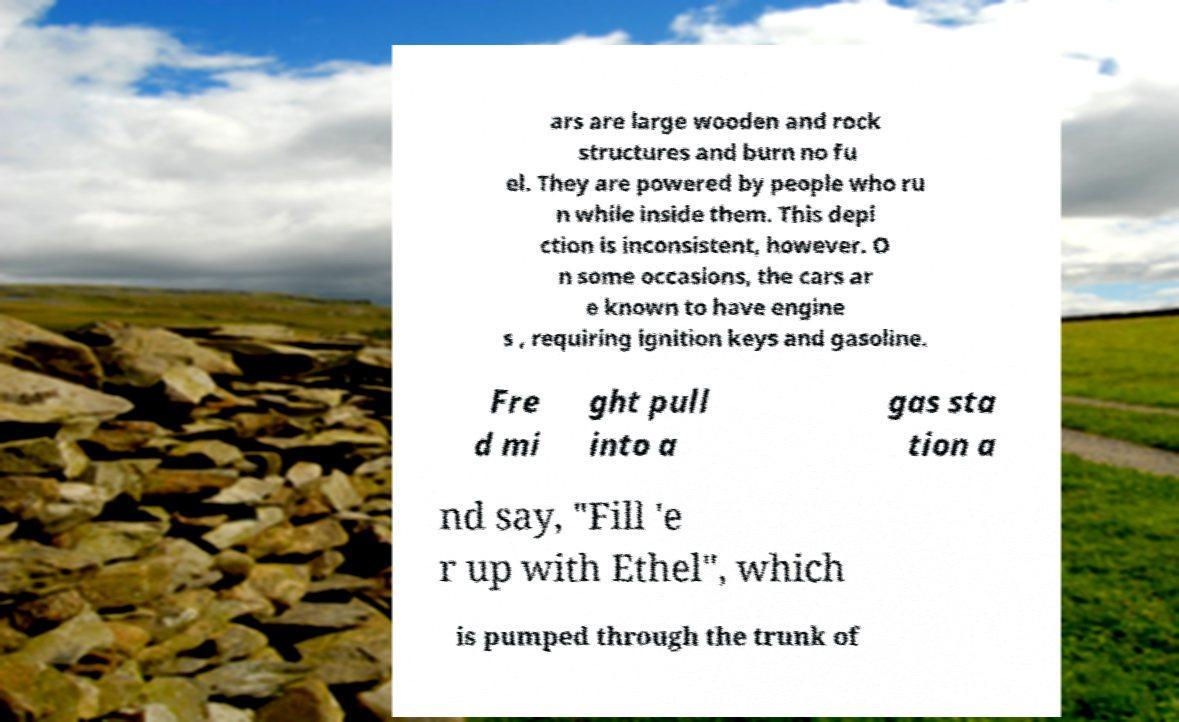For documentation purposes, I need the text within this image transcribed. Could you provide that? ars are large wooden and rock structures and burn no fu el. They are powered by people who ru n while inside them. This depi ction is inconsistent, however. O n some occasions, the cars ar e known to have engine s , requiring ignition keys and gasoline. Fre d mi ght pull into a gas sta tion a nd say, "Fill 'e r up with Ethel", which is pumped through the trunk of 